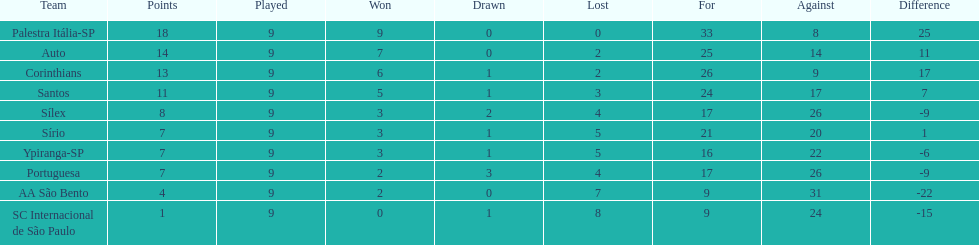Which team had the highest score? Palestra Itália-SP. 